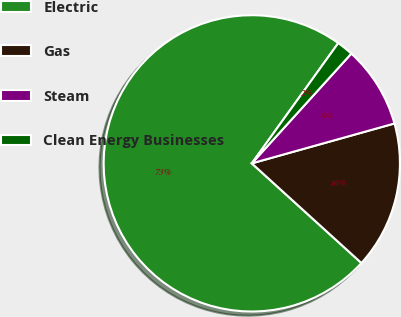Convert chart. <chart><loc_0><loc_0><loc_500><loc_500><pie_chart><fcel>Electric<fcel>Gas<fcel>Steam<fcel>Clean Energy Businesses<nl><fcel>73.18%<fcel>16.08%<fcel>8.94%<fcel>1.8%<nl></chart> 